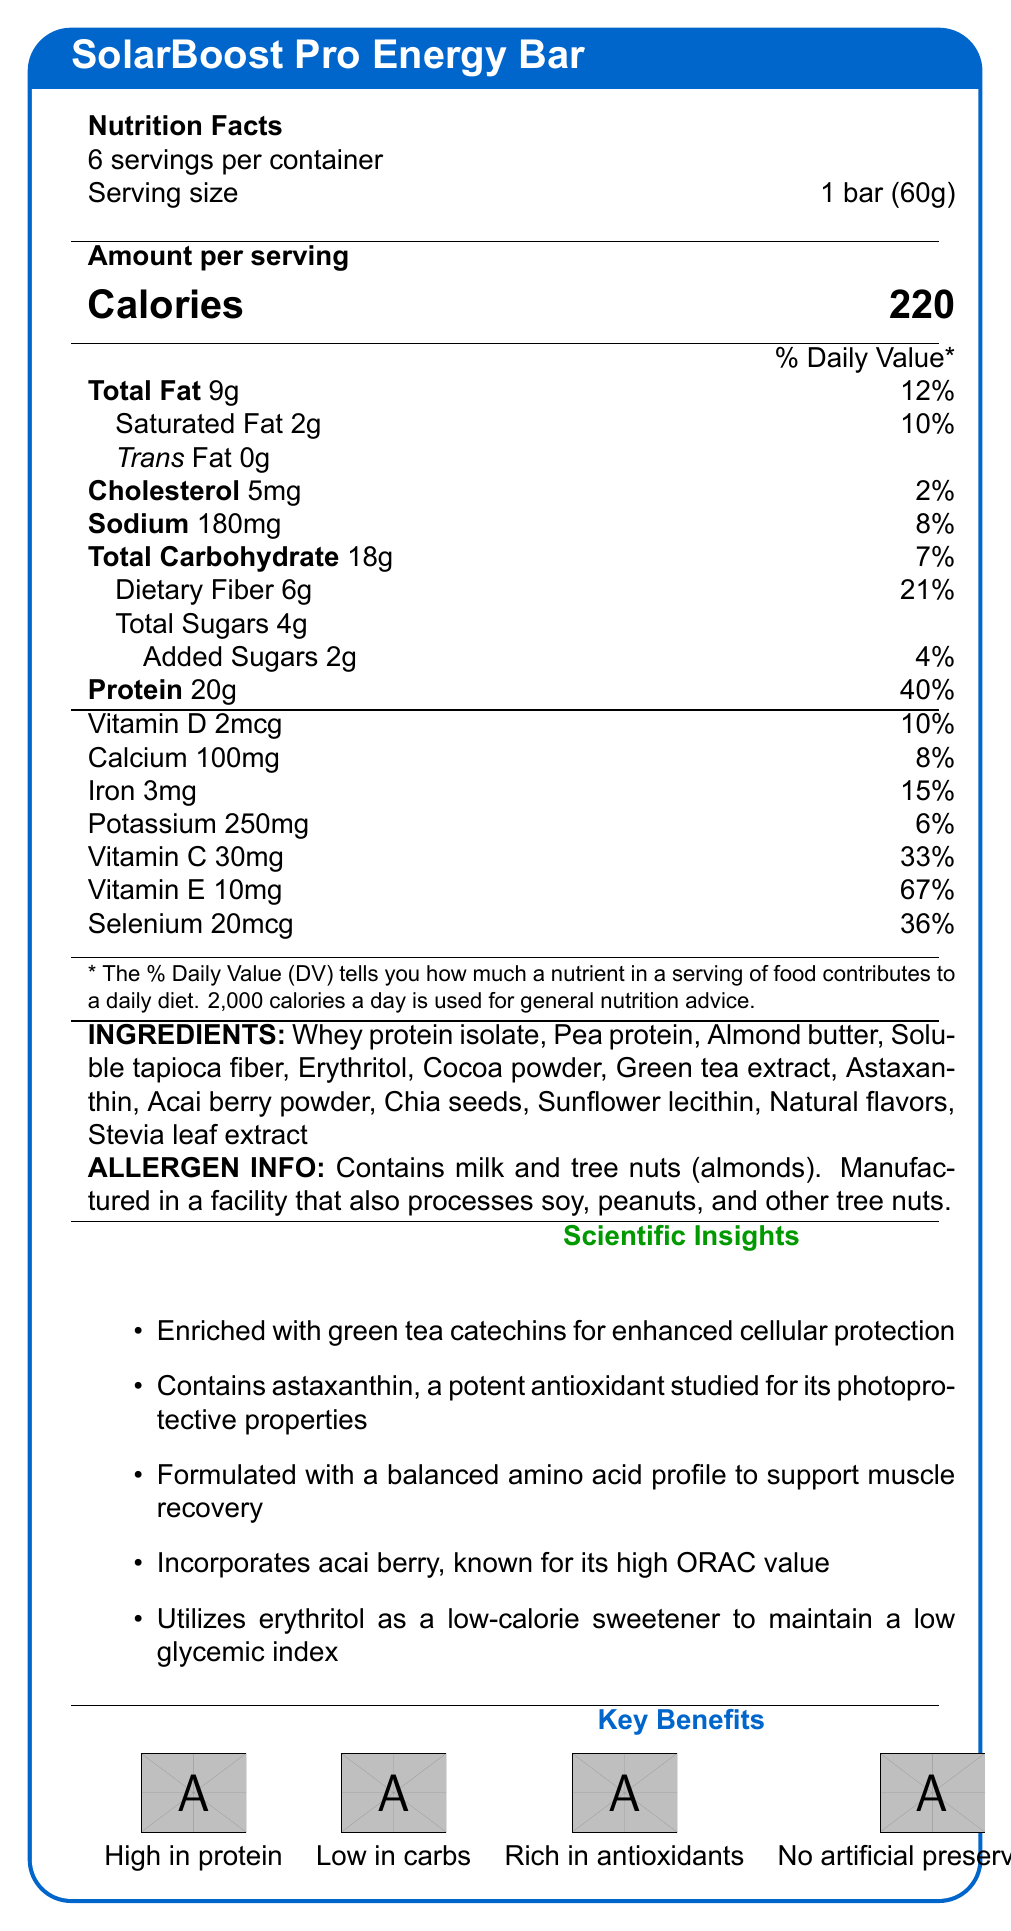what is the serving size of the SolarBoost Pro Energy Bar? As mentioned in the document, the serving size is explicitly indicated as "1 bar (60g)".
Answer: 1 bar (60g) how many calories are in a single serving of the energy bar? The document states that there are 220 calories per serving.
Answer: 220 how much protein does one bar provide? The amount of protein per serving is listed as "20g".
Answer: 20g what percentage of the daily value of Vitamin C is in one bar? The document states that one bar contains 33% of the daily value of Vitamin C.
Answer: 33% what are the main ingredients listed in the energy bar? The document contains a detailed list of ingredients starting with Whey protein isolate and ending with Stevia leaf extract.
Answer: Whey protein isolate, Pea protein, Almond butter, Soluble tapioca fiber, Erythritol, Cocoa powder, Green tea extract, Astaxanthin, Acai berry powder, Chia seeds, Sunflower lecithin, Natural flavors, Stevia leaf extract how much dietary fiber does one serving of the bar contain? The dietary fiber content per serving is specified as "6g".
Answer: 6g how many servings are there per container? It is stated in the document that there are 6 servings per container.
Answer: 6 which of the following vitamins is most abundant in the energy bar? A. Vitamin D B. Calcium C. Vitamin E D. Iron The document specifies that Vitamin E has the highest percentage of daily value at 67%, which is higher than the other vitamins listed.
Answer: C how much iron does a single energy bar provide? The document clearly lists the iron content as "3mg".
Answer: 3mg are there any artificial preservatives in the SolarBoost Pro Energy Bar? One of the key benefits listed is "No artificial preservatives."
Answer: No does the energy bar contain peanuts? The allergen information mentions that it is manufactured in a facility that processes peanuts, but it does not confirm if peanuts are in the bar itself.
Answer: Not enough information describe the main features and nutritional highlights of the SolarBoost Pro Energy Bar. The document outlines various attributes of the energy bar, including its high protein and antioxidant content, low-carb formulation, and specific nutrient contributions.
Answer: The SolarBoost Pro Energy Bar is a high-protein, low-carb energy bar designed to provide cellular protection with antioxidants like green tea catechins and astaxanthin. It offers 220 calories per serving, 20g of protein, and is rich in vitamins (C, E, D) and minerals (calcium, iron, selenium). The bar is gluten-free, contains no artificial preservatives, and is sweetened with low-calorie erythritol. which antioxidant mentioned in the document is known for its photoprotective properties? The document specifically states that astaxanthin is studied for its photoprotective properties.
Answer: Astaxanthin does the SolarBoost Pro Energy Bar contain any saturated fat? The document indicates that each serving contains 2g of saturated fat.
Answer: Yes what is the daily value percentage for sodium in one bar? Sodium content is listed with an accompanying daily value percentage of 8%.
Answer: 8% which sweetener is used in the SolarBoost Pro Energy Bar to maintain a low glycemic index? A. Sugar B. Stevia leaf extract C. Erythritol D. Honey The document mentions that erythritol is utilized as a low-calorie sweetener to maintain a low glycemic index.
Answer: C which ingredient in the SolarBoost Pro Energy Bar helps support muscle recovery with its balanced amino acid profile? One of the scientific insights points out that the bar is formulated with a balanced amino acid profile from ingredients like pea protein to support muscle recovery.
Answer: Pea protein how many grams of total sugars are there in one bar? The document indicates that there are 4g of total sugars per serving.
Answer: 4g is the energy bar gluten-free? Document explicitly mentions "Gluten-free" among its key benefits.
Answer: Yes 